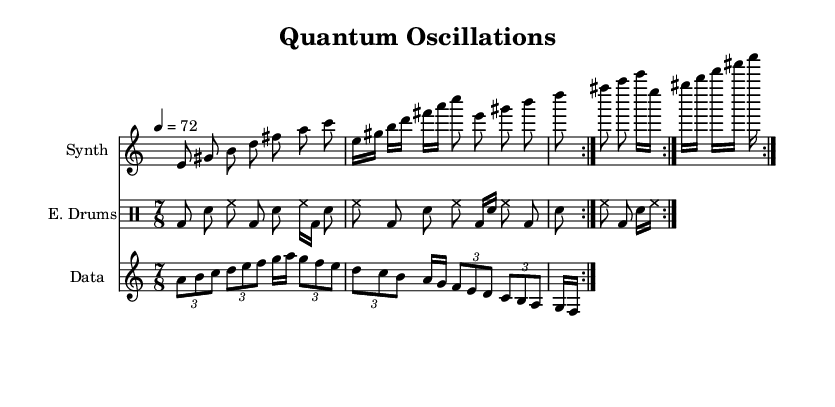What is the time signature of this music? The time signature is indicated at the beginning of the score where it displays "7/8". This means there are seven eighth notes per measure.
Answer: 7/8 What is the tempo marking in the piece? The tempo is indicated as "4 = 72" at the beginning of the score. This means that there are 72 beats per minute, with a quarter note defining the beat.
Answer: 72 How many times is the synthesizer section repeated? The synthesizer section is marked with "repeat volta 2", which indicates that it should be played two times.
Answer: 2 What type of notes are predominant in the synthesizer part? The synthesizer part consists mainly of eighth notes, as indicated by the notation, with some sixteenth notes appearing in a specific section.
Answer: Eighth notes What instrument is used for the electronic drums? The score names the drumming staff as "E. Drums," which stands for Electronic Drums, specifying the type of instruments used in that section.
Answer: Electronic Drums What is a notable characteristic of the sonified data section? The sonified data section features tuples, as illustrated by its use of "tuplet 3/2". This means that three notes are played in the duration typically occupied by two.
Answer: Tuplets How does the rhythm of the electronic drums change across repetitions? Observing the patterns, the rhythm of the electronic drums has variations in the order and duration of notes across the repetitions, demonstrating an evolving rhythmic structure typical of electronic music.
Answer: Varied rhythms 